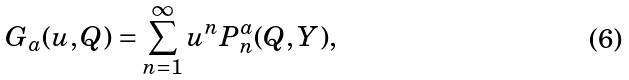<formula> <loc_0><loc_0><loc_500><loc_500>\ G _ { a } ( u , Q ) = \sum _ { n = 1 } ^ { \infty } u ^ { n } P _ { n } ^ { a } ( Q , Y ) ,</formula> 